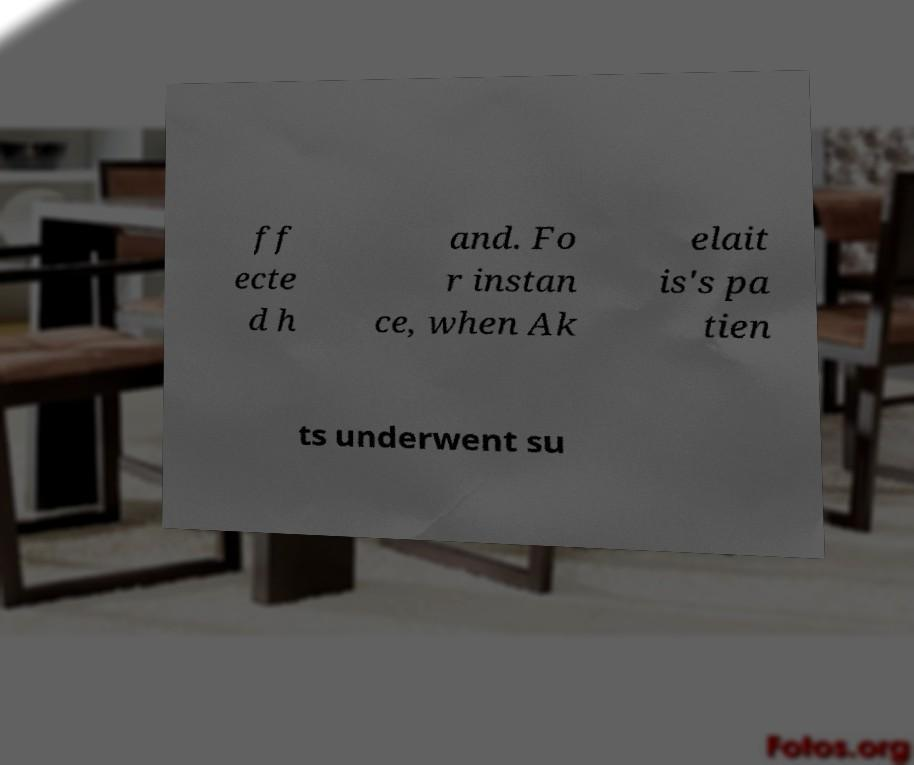Could you extract and type out the text from this image? ff ecte d h and. Fo r instan ce, when Ak elait is's pa tien ts underwent su 